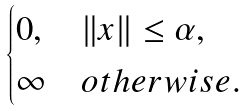Convert formula to latex. <formula><loc_0><loc_0><loc_500><loc_500>\begin{cases} 0 , & \| x \| \leq \alpha , \\ \infty & o t h e r w i s e . \end{cases}</formula> 